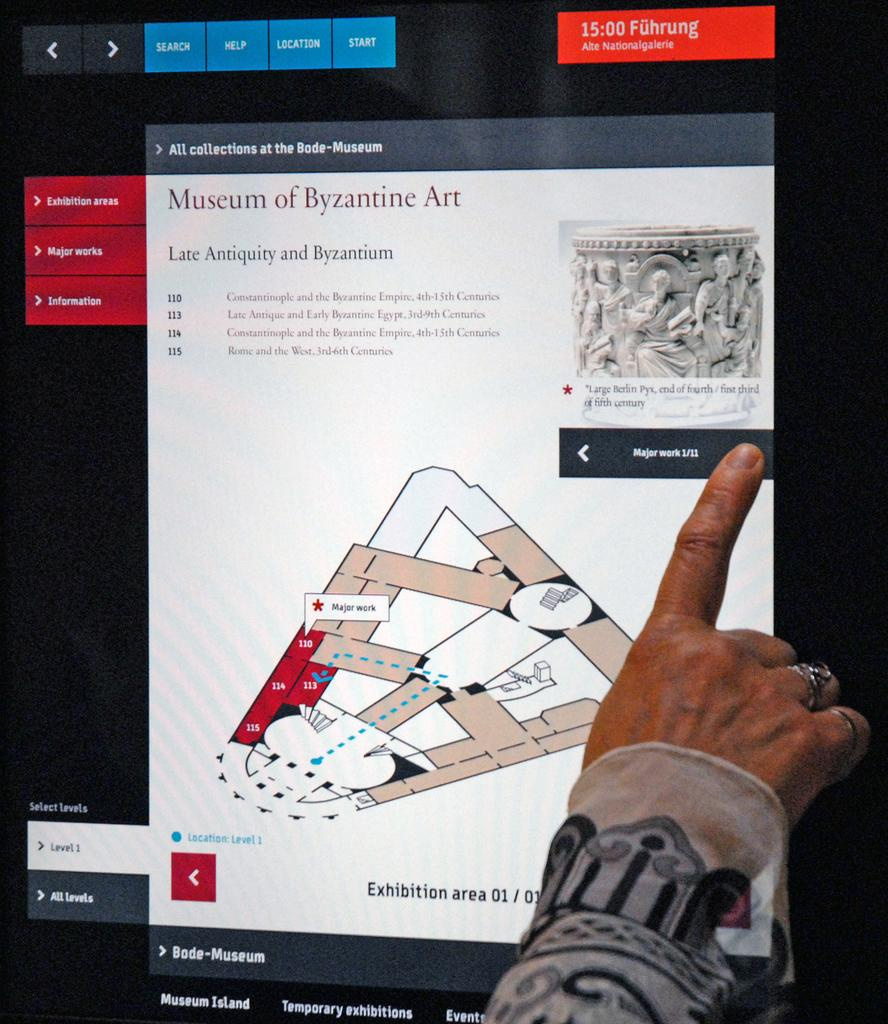What part of the human body is visible in the image? There is a human hand in the image. What is the hand doing or interacting with? The hand is wearing clothes and has finger rings. What is the main object that the hand is interacting with? There is a screen visible in the image. What can be seen on the screen? Text and pictures are present on the screen. How does the hand say good-bye to the cattle in the image? There are no cattle present in the image, and the hand is not interacting with any animals. 